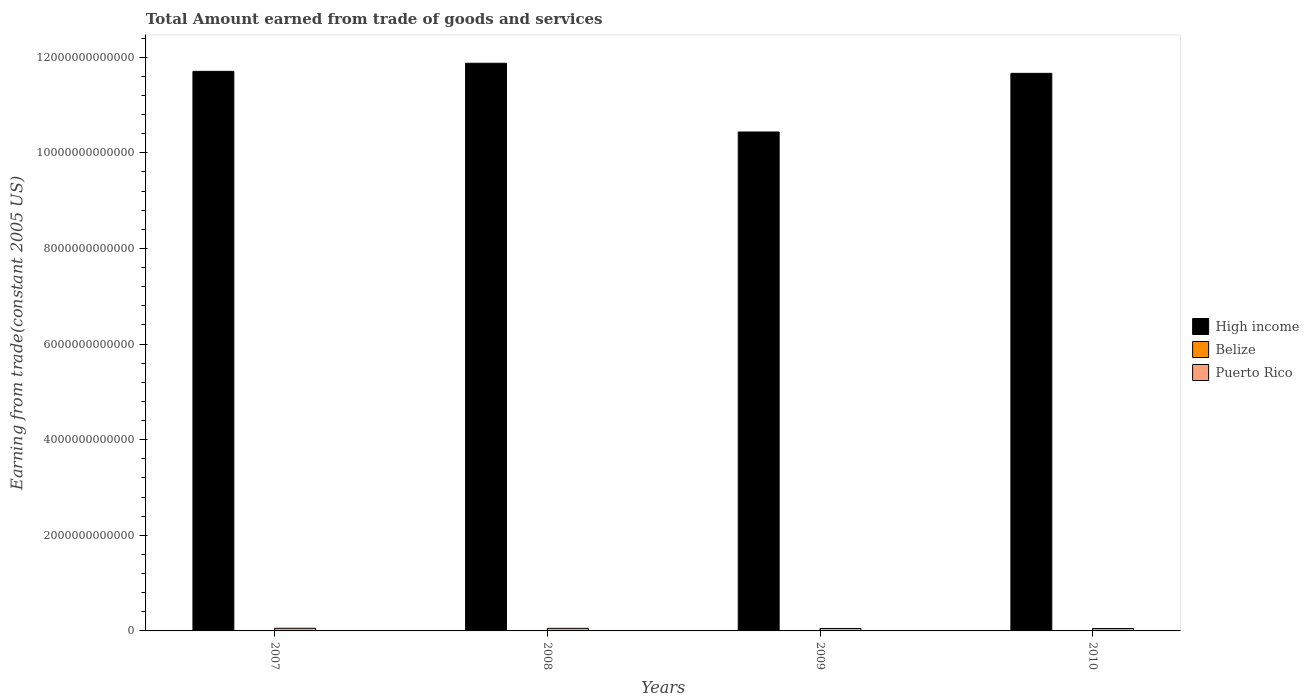Are the number of bars per tick equal to the number of legend labels?
Make the answer very short. Yes. What is the total amount earned by trading goods and services in Belize in 2010?
Give a very brief answer. 6.92e+08. Across all years, what is the maximum total amount earned by trading goods and services in Puerto Rico?
Give a very brief answer. 5.55e+1. Across all years, what is the minimum total amount earned by trading goods and services in Belize?
Give a very brief answer. 6.27e+08. What is the total total amount earned by trading goods and services in High income in the graph?
Provide a succinct answer. 4.57e+13. What is the difference between the total amount earned by trading goods and services in High income in 2008 and that in 2010?
Your answer should be compact. 2.11e+11. What is the difference between the total amount earned by trading goods and services in Belize in 2008 and the total amount earned by trading goods and services in Puerto Rico in 2010?
Provide a succinct answer. -4.89e+1. What is the average total amount earned by trading goods and services in Puerto Rico per year?
Your answer should be compact. 5.26e+1. In the year 2009, what is the difference between the total amount earned by trading goods and services in Puerto Rico and total amount earned by trading goods and services in High income?
Provide a succinct answer. -1.04e+13. In how many years, is the total amount earned by trading goods and services in Belize greater than 3600000000000 US$?
Your answer should be compact. 0. What is the ratio of the total amount earned by trading goods and services in Belize in 2007 to that in 2010?
Your answer should be very brief. 1.02. Is the total amount earned by trading goods and services in Belize in 2008 less than that in 2009?
Your answer should be compact. No. Is the difference between the total amount earned by trading goods and services in Puerto Rico in 2008 and 2010 greater than the difference between the total amount earned by trading goods and services in High income in 2008 and 2010?
Your answer should be very brief. No. What is the difference between the highest and the second highest total amount earned by trading goods and services in High income?
Offer a very short reply. 1.69e+11. What is the difference between the highest and the lowest total amount earned by trading goods and services in Belize?
Your answer should be very brief. 1.70e+08. Is the sum of the total amount earned by trading goods and services in Puerto Rico in 2009 and 2010 greater than the maximum total amount earned by trading goods and services in High income across all years?
Your answer should be compact. No. What does the 3rd bar from the left in 2010 represents?
Make the answer very short. Puerto Rico. Is it the case that in every year, the sum of the total amount earned by trading goods and services in High income and total amount earned by trading goods and services in Belize is greater than the total amount earned by trading goods and services in Puerto Rico?
Ensure brevity in your answer.  Yes. How many bars are there?
Keep it short and to the point. 12. Are all the bars in the graph horizontal?
Your response must be concise. No. How many years are there in the graph?
Your response must be concise. 4. What is the difference between two consecutive major ticks on the Y-axis?
Offer a terse response. 2.00e+12. Are the values on the major ticks of Y-axis written in scientific E-notation?
Offer a very short reply. No. Does the graph contain grids?
Your answer should be compact. No. Where does the legend appear in the graph?
Offer a very short reply. Center right. How many legend labels are there?
Your answer should be compact. 3. How are the legend labels stacked?
Your response must be concise. Vertical. What is the title of the graph?
Ensure brevity in your answer.  Total Amount earned from trade of goods and services. Does "Syrian Arab Republic" appear as one of the legend labels in the graph?
Offer a terse response. No. What is the label or title of the Y-axis?
Offer a very short reply. Earning from trade(constant 2005 US). What is the Earning from trade(constant 2005 US) in High income in 2007?
Provide a succinct answer. 1.17e+13. What is the Earning from trade(constant 2005 US) of Belize in 2007?
Your response must be concise. 7.04e+08. What is the Earning from trade(constant 2005 US) in Puerto Rico in 2007?
Your answer should be very brief. 5.55e+1. What is the Earning from trade(constant 2005 US) in High income in 2008?
Your response must be concise. 1.19e+13. What is the Earning from trade(constant 2005 US) of Belize in 2008?
Make the answer very short. 7.97e+08. What is the Earning from trade(constant 2005 US) of Puerto Rico in 2008?
Make the answer very short. 5.41e+1. What is the Earning from trade(constant 2005 US) of High income in 2009?
Make the answer very short. 1.04e+13. What is the Earning from trade(constant 2005 US) of Belize in 2009?
Offer a terse response. 6.27e+08. What is the Earning from trade(constant 2005 US) in Puerto Rico in 2009?
Ensure brevity in your answer.  5.13e+1. What is the Earning from trade(constant 2005 US) in High income in 2010?
Ensure brevity in your answer.  1.17e+13. What is the Earning from trade(constant 2005 US) of Belize in 2010?
Offer a terse response. 6.92e+08. What is the Earning from trade(constant 2005 US) of Puerto Rico in 2010?
Your response must be concise. 4.97e+1. Across all years, what is the maximum Earning from trade(constant 2005 US) of High income?
Provide a short and direct response. 1.19e+13. Across all years, what is the maximum Earning from trade(constant 2005 US) of Belize?
Provide a succinct answer. 7.97e+08. Across all years, what is the maximum Earning from trade(constant 2005 US) in Puerto Rico?
Offer a very short reply. 5.55e+1. Across all years, what is the minimum Earning from trade(constant 2005 US) in High income?
Make the answer very short. 1.04e+13. Across all years, what is the minimum Earning from trade(constant 2005 US) of Belize?
Offer a terse response. 6.27e+08. Across all years, what is the minimum Earning from trade(constant 2005 US) of Puerto Rico?
Offer a very short reply. 4.97e+1. What is the total Earning from trade(constant 2005 US) of High income in the graph?
Your answer should be compact. 4.57e+13. What is the total Earning from trade(constant 2005 US) in Belize in the graph?
Your response must be concise. 2.82e+09. What is the total Earning from trade(constant 2005 US) of Puerto Rico in the graph?
Offer a terse response. 2.11e+11. What is the difference between the Earning from trade(constant 2005 US) of High income in 2007 and that in 2008?
Offer a very short reply. -1.69e+11. What is the difference between the Earning from trade(constant 2005 US) in Belize in 2007 and that in 2008?
Offer a very short reply. -9.29e+07. What is the difference between the Earning from trade(constant 2005 US) of Puerto Rico in 2007 and that in 2008?
Provide a short and direct response. 1.38e+09. What is the difference between the Earning from trade(constant 2005 US) in High income in 2007 and that in 2009?
Your answer should be compact. 1.27e+12. What is the difference between the Earning from trade(constant 2005 US) of Belize in 2007 and that in 2009?
Give a very brief answer. 7.73e+07. What is the difference between the Earning from trade(constant 2005 US) of Puerto Rico in 2007 and that in 2009?
Your answer should be very brief. 4.20e+09. What is the difference between the Earning from trade(constant 2005 US) in High income in 2007 and that in 2010?
Provide a succinct answer. 4.20e+1. What is the difference between the Earning from trade(constant 2005 US) of Belize in 2007 and that in 2010?
Your response must be concise. 1.26e+07. What is the difference between the Earning from trade(constant 2005 US) in Puerto Rico in 2007 and that in 2010?
Ensure brevity in your answer.  5.73e+09. What is the difference between the Earning from trade(constant 2005 US) of High income in 2008 and that in 2009?
Make the answer very short. 1.44e+12. What is the difference between the Earning from trade(constant 2005 US) of Belize in 2008 and that in 2009?
Your answer should be very brief. 1.70e+08. What is the difference between the Earning from trade(constant 2005 US) in Puerto Rico in 2008 and that in 2009?
Provide a succinct answer. 2.82e+09. What is the difference between the Earning from trade(constant 2005 US) in High income in 2008 and that in 2010?
Offer a very short reply. 2.11e+11. What is the difference between the Earning from trade(constant 2005 US) in Belize in 2008 and that in 2010?
Your answer should be very brief. 1.05e+08. What is the difference between the Earning from trade(constant 2005 US) of Puerto Rico in 2008 and that in 2010?
Make the answer very short. 4.35e+09. What is the difference between the Earning from trade(constant 2005 US) of High income in 2009 and that in 2010?
Make the answer very short. -1.23e+12. What is the difference between the Earning from trade(constant 2005 US) of Belize in 2009 and that in 2010?
Make the answer very short. -6.47e+07. What is the difference between the Earning from trade(constant 2005 US) of Puerto Rico in 2009 and that in 2010?
Make the answer very short. 1.53e+09. What is the difference between the Earning from trade(constant 2005 US) of High income in 2007 and the Earning from trade(constant 2005 US) of Belize in 2008?
Your response must be concise. 1.17e+13. What is the difference between the Earning from trade(constant 2005 US) of High income in 2007 and the Earning from trade(constant 2005 US) of Puerto Rico in 2008?
Make the answer very short. 1.17e+13. What is the difference between the Earning from trade(constant 2005 US) in Belize in 2007 and the Earning from trade(constant 2005 US) in Puerto Rico in 2008?
Your answer should be very brief. -5.34e+1. What is the difference between the Earning from trade(constant 2005 US) in High income in 2007 and the Earning from trade(constant 2005 US) in Belize in 2009?
Give a very brief answer. 1.17e+13. What is the difference between the Earning from trade(constant 2005 US) of High income in 2007 and the Earning from trade(constant 2005 US) of Puerto Rico in 2009?
Your answer should be compact. 1.17e+13. What is the difference between the Earning from trade(constant 2005 US) of Belize in 2007 and the Earning from trade(constant 2005 US) of Puerto Rico in 2009?
Keep it short and to the point. -5.06e+1. What is the difference between the Earning from trade(constant 2005 US) in High income in 2007 and the Earning from trade(constant 2005 US) in Belize in 2010?
Offer a very short reply. 1.17e+13. What is the difference between the Earning from trade(constant 2005 US) in High income in 2007 and the Earning from trade(constant 2005 US) in Puerto Rico in 2010?
Ensure brevity in your answer.  1.17e+13. What is the difference between the Earning from trade(constant 2005 US) of Belize in 2007 and the Earning from trade(constant 2005 US) of Puerto Rico in 2010?
Your response must be concise. -4.90e+1. What is the difference between the Earning from trade(constant 2005 US) in High income in 2008 and the Earning from trade(constant 2005 US) in Belize in 2009?
Give a very brief answer. 1.19e+13. What is the difference between the Earning from trade(constant 2005 US) of High income in 2008 and the Earning from trade(constant 2005 US) of Puerto Rico in 2009?
Make the answer very short. 1.18e+13. What is the difference between the Earning from trade(constant 2005 US) of Belize in 2008 and the Earning from trade(constant 2005 US) of Puerto Rico in 2009?
Your answer should be very brief. -5.05e+1. What is the difference between the Earning from trade(constant 2005 US) in High income in 2008 and the Earning from trade(constant 2005 US) in Belize in 2010?
Keep it short and to the point. 1.19e+13. What is the difference between the Earning from trade(constant 2005 US) of High income in 2008 and the Earning from trade(constant 2005 US) of Puerto Rico in 2010?
Ensure brevity in your answer.  1.18e+13. What is the difference between the Earning from trade(constant 2005 US) of Belize in 2008 and the Earning from trade(constant 2005 US) of Puerto Rico in 2010?
Your response must be concise. -4.89e+1. What is the difference between the Earning from trade(constant 2005 US) in High income in 2009 and the Earning from trade(constant 2005 US) in Belize in 2010?
Offer a terse response. 1.04e+13. What is the difference between the Earning from trade(constant 2005 US) of High income in 2009 and the Earning from trade(constant 2005 US) of Puerto Rico in 2010?
Your answer should be very brief. 1.04e+13. What is the difference between the Earning from trade(constant 2005 US) in Belize in 2009 and the Earning from trade(constant 2005 US) in Puerto Rico in 2010?
Your response must be concise. -4.91e+1. What is the average Earning from trade(constant 2005 US) in High income per year?
Provide a succinct answer. 1.14e+13. What is the average Earning from trade(constant 2005 US) in Belize per year?
Your answer should be compact. 7.05e+08. What is the average Earning from trade(constant 2005 US) in Puerto Rico per year?
Provide a succinct answer. 5.26e+1. In the year 2007, what is the difference between the Earning from trade(constant 2005 US) in High income and Earning from trade(constant 2005 US) in Belize?
Your response must be concise. 1.17e+13. In the year 2007, what is the difference between the Earning from trade(constant 2005 US) of High income and Earning from trade(constant 2005 US) of Puerto Rico?
Your answer should be very brief. 1.16e+13. In the year 2007, what is the difference between the Earning from trade(constant 2005 US) in Belize and Earning from trade(constant 2005 US) in Puerto Rico?
Keep it short and to the point. -5.48e+1. In the year 2008, what is the difference between the Earning from trade(constant 2005 US) in High income and Earning from trade(constant 2005 US) in Belize?
Provide a succinct answer. 1.19e+13. In the year 2008, what is the difference between the Earning from trade(constant 2005 US) of High income and Earning from trade(constant 2005 US) of Puerto Rico?
Ensure brevity in your answer.  1.18e+13. In the year 2008, what is the difference between the Earning from trade(constant 2005 US) of Belize and Earning from trade(constant 2005 US) of Puerto Rico?
Make the answer very short. -5.33e+1. In the year 2009, what is the difference between the Earning from trade(constant 2005 US) in High income and Earning from trade(constant 2005 US) in Belize?
Offer a very short reply. 1.04e+13. In the year 2009, what is the difference between the Earning from trade(constant 2005 US) of High income and Earning from trade(constant 2005 US) of Puerto Rico?
Keep it short and to the point. 1.04e+13. In the year 2009, what is the difference between the Earning from trade(constant 2005 US) of Belize and Earning from trade(constant 2005 US) of Puerto Rico?
Provide a short and direct response. -5.06e+1. In the year 2010, what is the difference between the Earning from trade(constant 2005 US) of High income and Earning from trade(constant 2005 US) of Belize?
Make the answer very short. 1.17e+13. In the year 2010, what is the difference between the Earning from trade(constant 2005 US) of High income and Earning from trade(constant 2005 US) of Puerto Rico?
Your answer should be very brief. 1.16e+13. In the year 2010, what is the difference between the Earning from trade(constant 2005 US) in Belize and Earning from trade(constant 2005 US) in Puerto Rico?
Give a very brief answer. -4.90e+1. What is the ratio of the Earning from trade(constant 2005 US) of High income in 2007 to that in 2008?
Make the answer very short. 0.99. What is the ratio of the Earning from trade(constant 2005 US) of Belize in 2007 to that in 2008?
Provide a succinct answer. 0.88. What is the ratio of the Earning from trade(constant 2005 US) of Puerto Rico in 2007 to that in 2008?
Ensure brevity in your answer.  1.03. What is the ratio of the Earning from trade(constant 2005 US) of High income in 2007 to that in 2009?
Offer a terse response. 1.12. What is the ratio of the Earning from trade(constant 2005 US) of Belize in 2007 to that in 2009?
Your response must be concise. 1.12. What is the ratio of the Earning from trade(constant 2005 US) in Puerto Rico in 2007 to that in 2009?
Your answer should be very brief. 1.08. What is the ratio of the Earning from trade(constant 2005 US) in High income in 2007 to that in 2010?
Your answer should be compact. 1. What is the ratio of the Earning from trade(constant 2005 US) in Belize in 2007 to that in 2010?
Your response must be concise. 1.02. What is the ratio of the Earning from trade(constant 2005 US) in Puerto Rico in 2007 to that in 2010?
Your answer should be compact. 1.12. What is the ratio of the Earning from trade(constant 2005 US) in High income in 2008 to that in 2009?
Provide a succinct answer. 1.14. What is the ratio of the Earning from trade(constant 2005 US) of Belize in 2008 to that in 2009?
Keep it short and to the point. 1.27. What is the ratio of the Earning from trade(constant 2005 US) of Puerto Rico in 2008 to that in 2009?
Offer a very short reply. 1.05. What is the ratio of the Earning from trade(constant 2005 US) of High income in 2008 to that in 2010?
Offer a terse response. 1.02. What is the ratio of the Earning from trade(constant 2005 US) in Belize in 2008 to that in 2010?
Your response must be concise. 1.15. What is the ratio of the Earning from trade(constant 2005 US) in Puerto Rico in 2008 to that in 2010?
Your answer should be compact. 1.09. What is the ratio of the Earning from trade(constant 2005 US) of High income in 2009 to that in 2010?
Provide a succinct answer. 0.89. What is the ratio of the Earning from trade(constant 2005 US) in Belize in 2009 to that in 2010?
Offer a terse response. 0.91. What is the ratio of the Earning from trade(constant 2005 US) in Puerto Rico in 2009 to that in 2010?
Offer a very short reply. 1.03. What is the difference between the highest and the second highest Earning from trade(constant 2005 US) of High income?
Keep it short and to the point. 1.69e+11. What is the difference between the highest and the second highest Earning from trade(constant 2005 US) in Belize?
Ensure brevity in your answer.  9.29e+07. What is the difference between the highest and the second highest Earning from trade(constant 2005 US) in Puerto Rico?
Provide a short and direct response. 1.38e+09. What is the difference between the highest and the lowest Earning from trade(constant 2005 US) in High income?
Offer a very short reply. 1.44e+12. What is the difference between the highest and the lowest Earning from trade(constant 2005 US) of Belize?
Your answer should be very brief. 1.70e+08. What is the difference between the highest and the lowest Earning from trade(constant 2005 US) in Puerto Rico?
Your answer should be compact. 5.73e+09. 